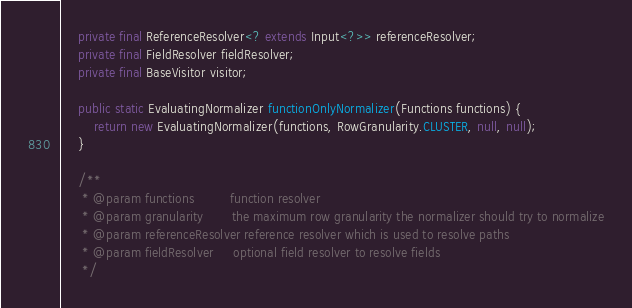Convert code to text. <code><loc_0><loc_0><loc_500><loc_500><_Java_>    private final ReferenceResolver<? extends Input<?>> referenceResolver;
    private final FieldResolver fieldResolver;
    private final BaseVisitor visitor;

    public static EvaluatingNormalizer functionOnlyNormalizer(Functions functions) {
        return new EvaluatingNormalizer(functions, RowGranularity.CLUSTER, null, null);
    }

    /**
     * @param functions         function resolver
     * @param granularity       the maximum row granularity the normalizer should try to normalize
     * @param referenceResolver reference resolver which is used to resolve paths
     * @param fieldResolver     optional field resolver to resolve fields
     */</code> 